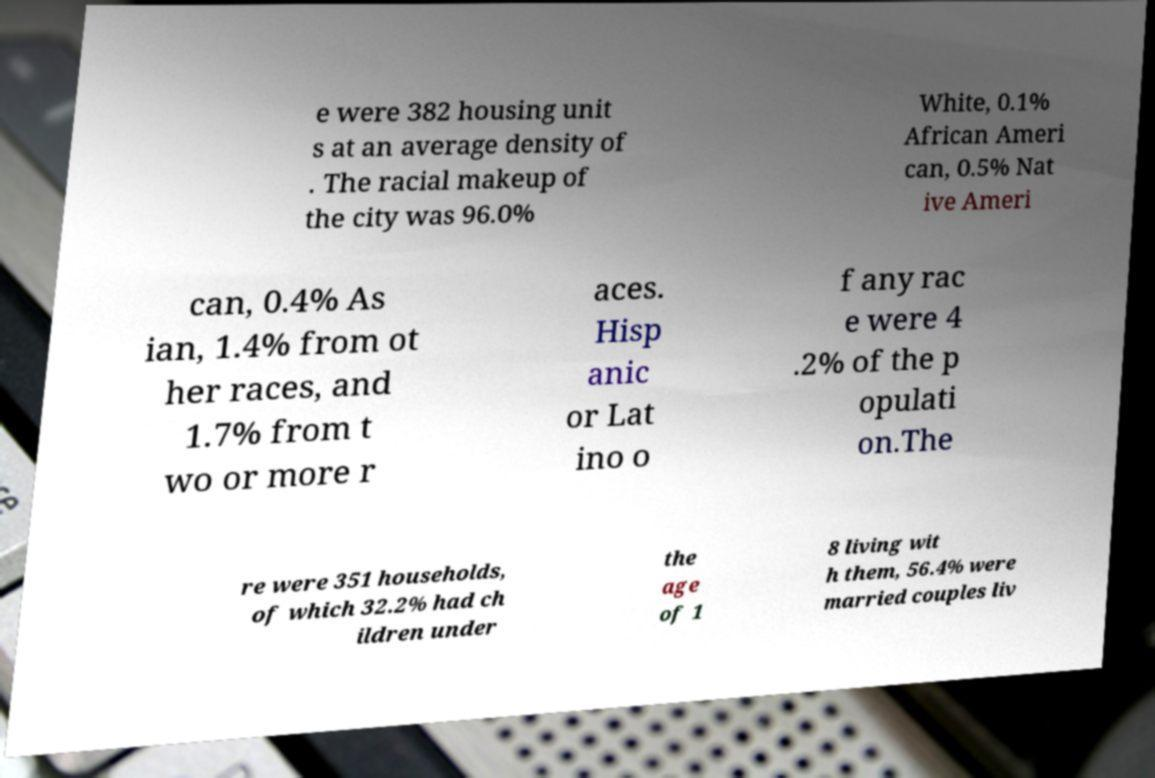Could you extract and type out the text from this image? e were 382 housing unit s at an average density of . The racial makeup of the city was 96.0% White, 0.1% African Ameri can, 0.5% Nat ive Ameri can, 0.4% As ian, 1.4% from ot her races, and 1.7% from t wo or more r aces. Hisp anic or Lat ino o f any rac e were 4 .2% of the p opulati on.The re were 351 households, of which 32.2% had ch ildren under the age of 1 8 living wit h them, 56.4% were married couples liv 